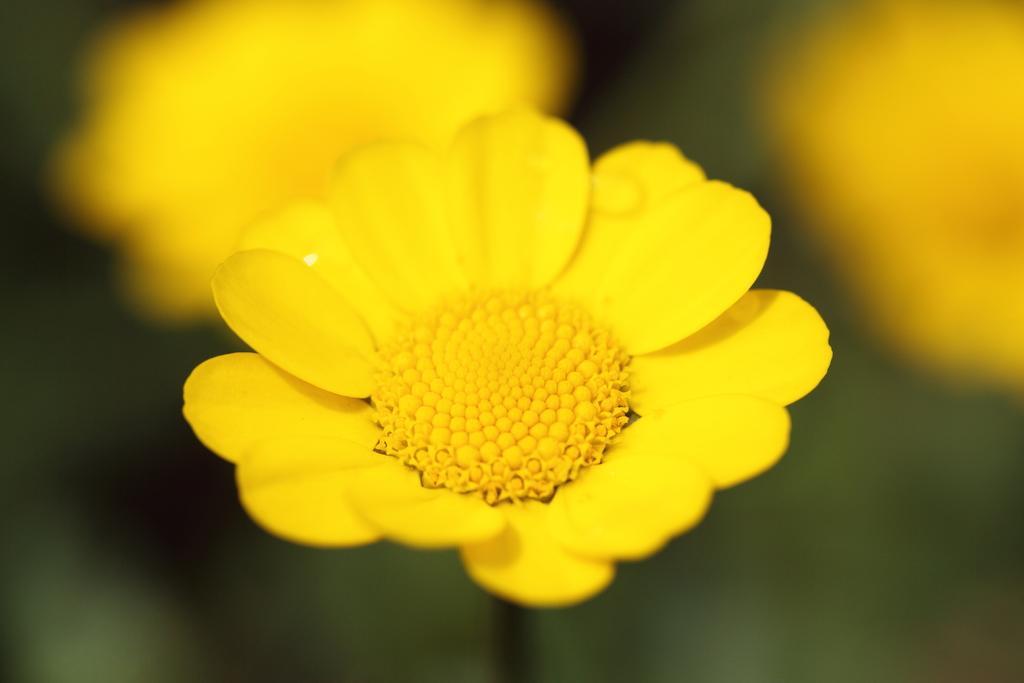How would you summarize this image in a sentence or two? In this picture we can see flowers and in the background it is blurry. 